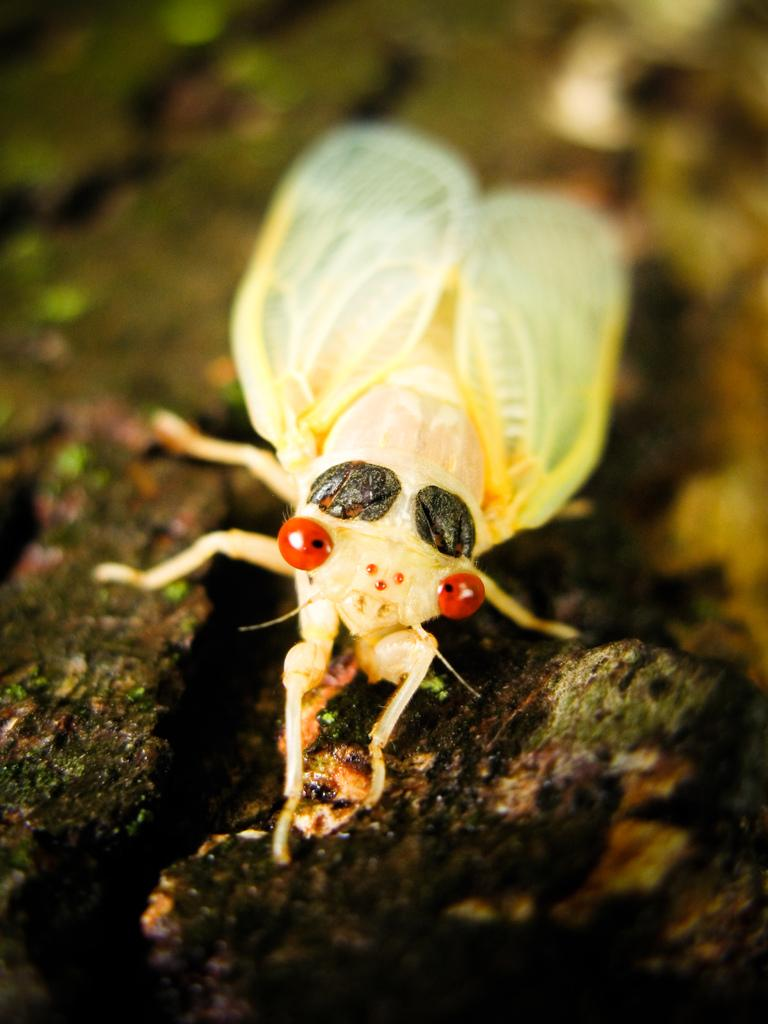What type of creature is in the image? There is a white-colored insect in the image. Where is the insect located? The insect is on the ground. How many sheep are visible in the image? There are no sheep present in the image; it features a white-colored insect on the ground. What type of jelly is being used to hold the insect in place? There is no jelly present in the image, and the insect is not being held in place by any substance. 